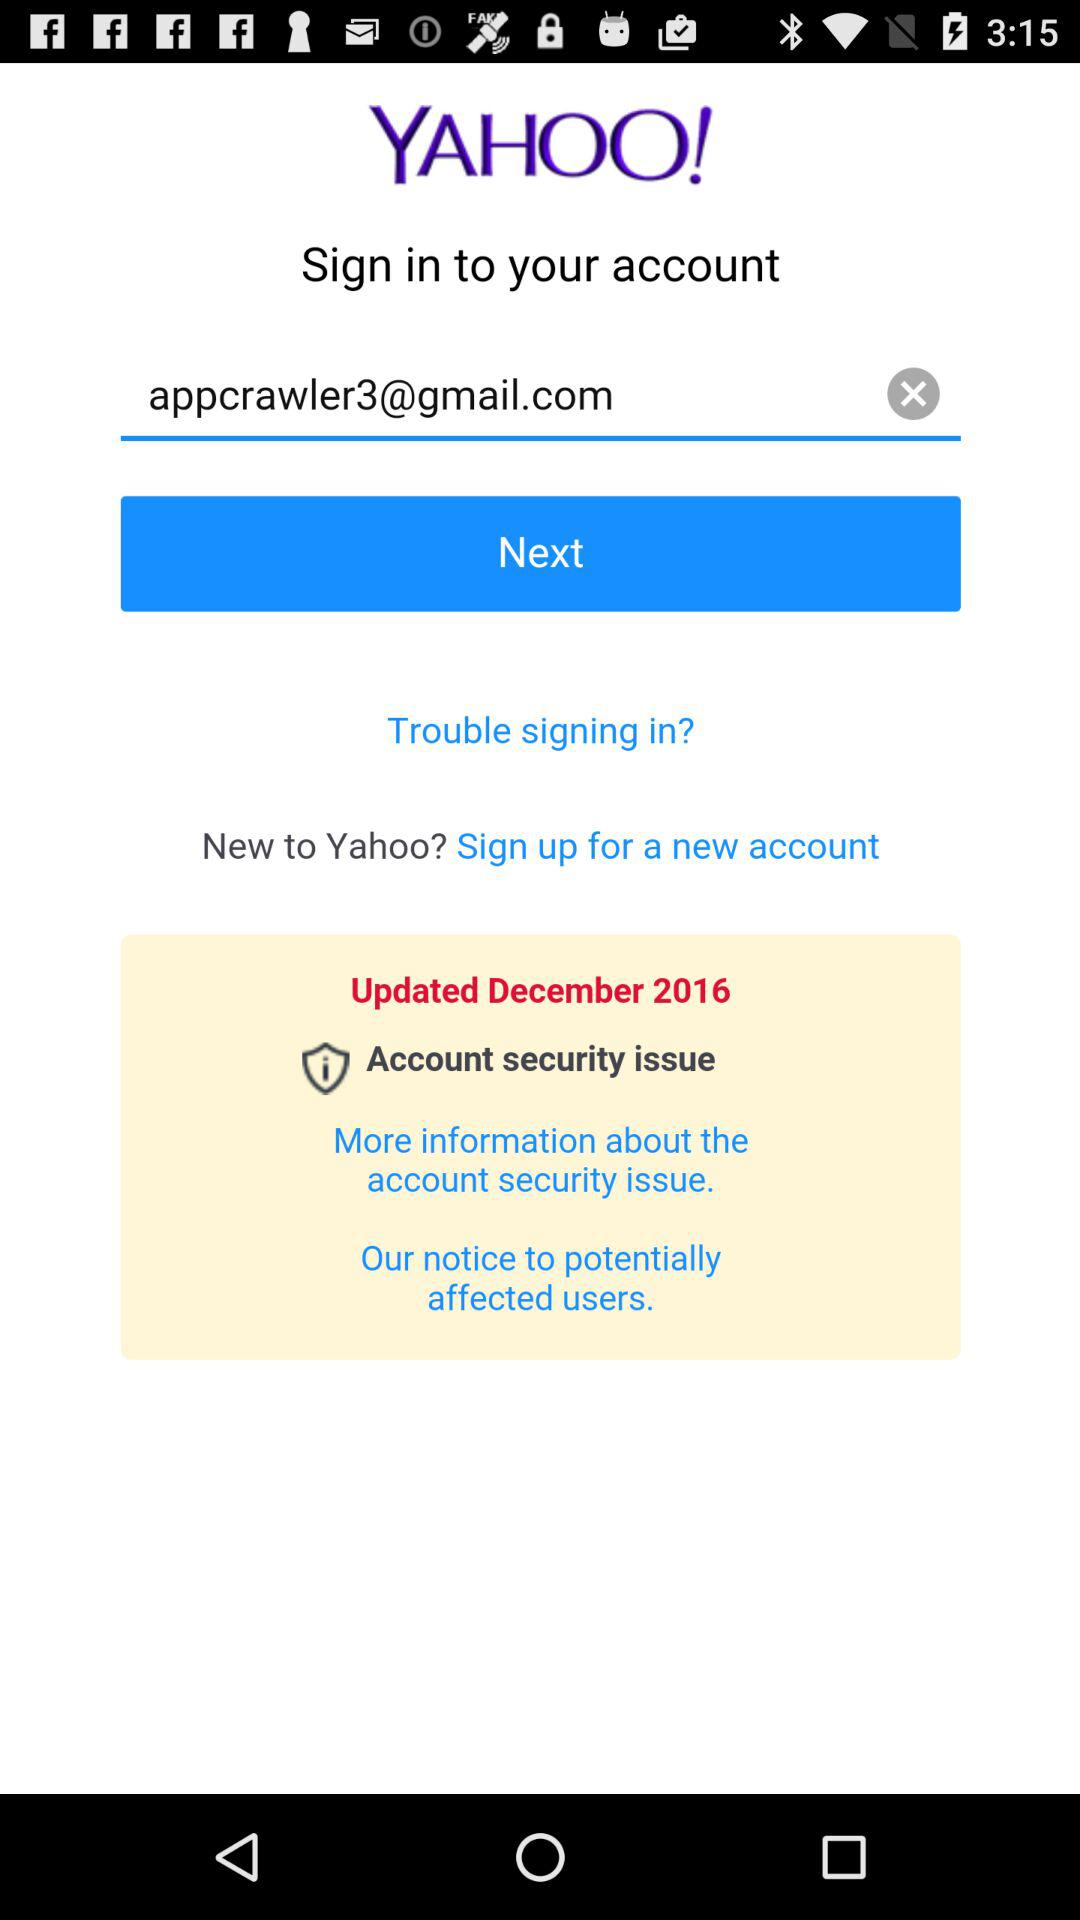What is the user name?
When the provided information is insufficient, respond with <no answer>. <no answer> 